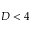Convert formula to latex. <formula><loc_0><loc_0><loc_500><loc_500>D < 4</formula> 